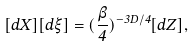Convert formula to latex. <formula><loc_0><loc_0><loc_500><loc_500>[ d X ] [ d \xi ] = ( \frac { \beta } { 4 } ) ^ { - 3 D / 4 } [ d Z ] ,</formula> 